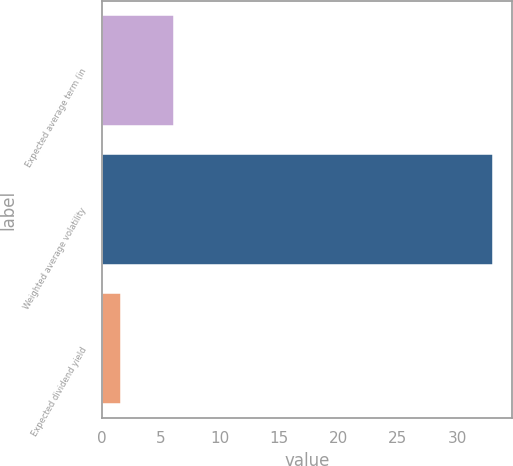Convert chart. <chart><loc_0><loc_0><loc_500><loc_500><bar_chart><fcel>Expected average term (in<fcel>Weighted average volatility<fcel>Expected dividend yield<nl><fcel>6.1<fcel>33<fcel>1.6<nl></chart> 